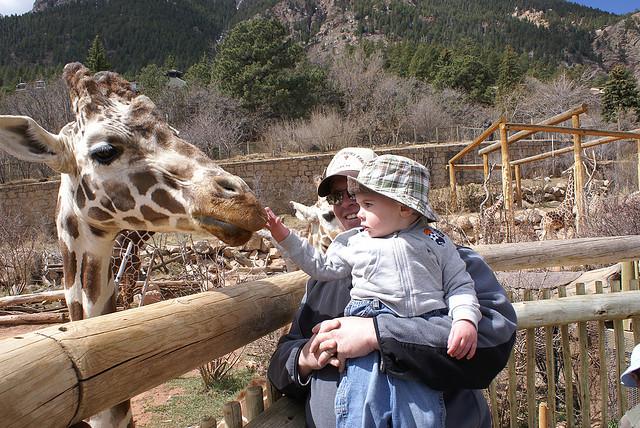Is the baby petting the giraffe?
Answer briefly. Yes. How many people wearing hats?
Be succinct. 2. Does the child appear frightened?
Answer briefly. No. 